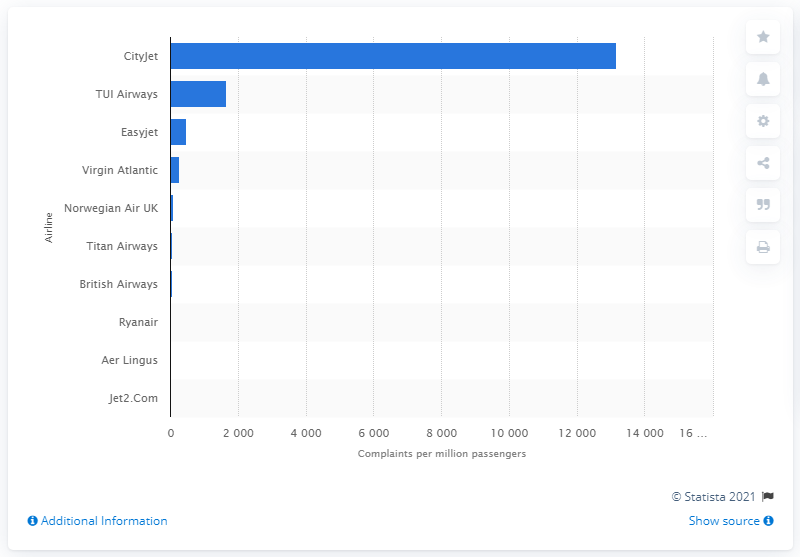Identify some key points in this picture. Aer Lingus received 16 complaints per million passengers in the second quarter of 2020. 